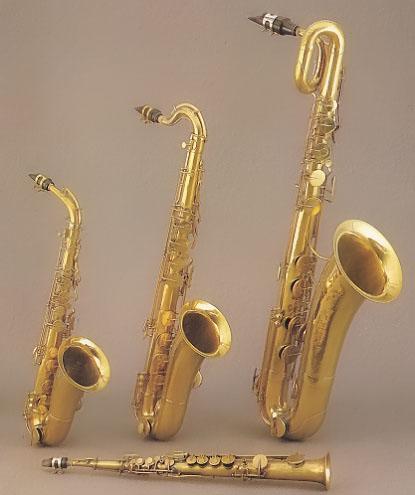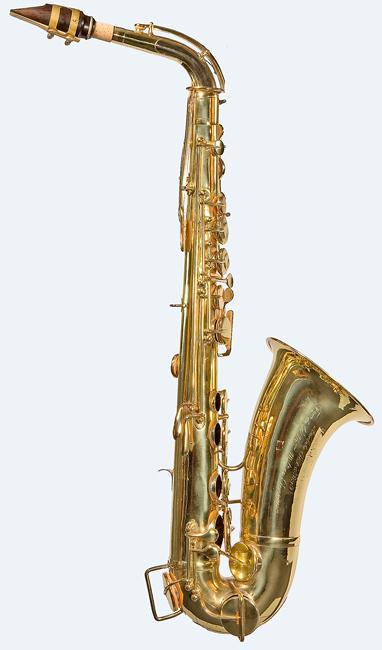The first image is the image on the left, the second image is the image on the right. Assess this claim about the two images: "Exactly two saxophones are shown, the same color, but angled differently at the mouthpiece area.". Correct or not? Answer yes or no. No. The first image is the image on the left, the second image is the image on the right. Assess this claim about the two images: "Each image contains one saxophone displayed at some angle, with its bell facing rightward, and one image features a silver saxophone with a brown tip at one end.". Correct or not? Answer yes or no. No. 